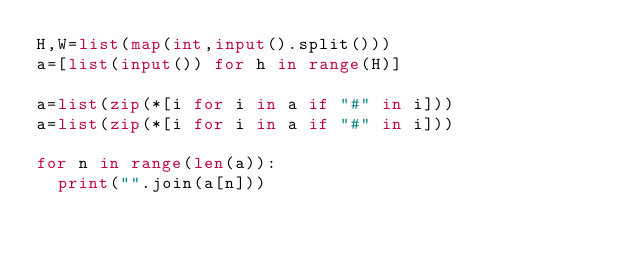Convert code to text. <code><loc_0><loc_0><loc_500><loc_500><_Python_>H,W=list(map(int,input().split()))
a=[list(input()) for h in range(H)] 

a=list(zip(*[i for i in a if "#" in i]))
a=list(zip(*[i for i in a if "#" in i]))

for n in range(len(a)):
  print("".join(a[n]))
</code> 